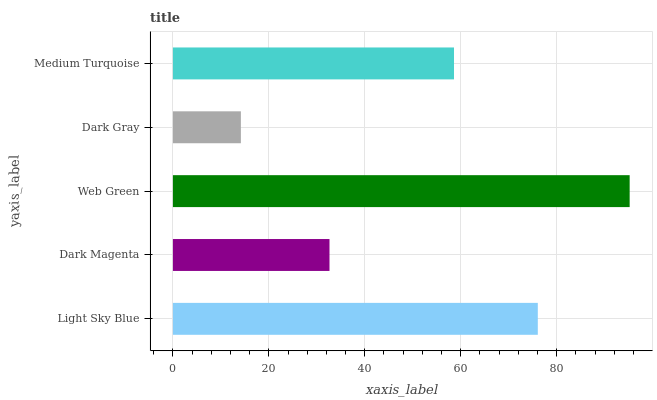Is Dark Gray the minimum?
Answer yes or no. Yes. Is Web Green the maximum?
Answer yes or no. Yes. Is Dark Magenta the minimum?
Answer yes or no. No. Is Dark Magenta the maximum?
Answer yes or no. No. Is Light Sky Blue greater than Dark Magenta?
Answer yes or no. Yes. Is Dark Magenta less than Light Sky Blue?
Answer yes or no. Yes. Is Dark Magenta greater than Light Sky Blue?
Answer yes or no. No. Is Light Sky Blue less than Dark Magenta?
Answer yes or no. No. Is Medium Turquoise the high median?
Answer yes or no. Yes. Is Medium Turquoise the low median?
Answer yes or no. Yes. Is Dark Gray the high median?
Answer yes or no. No. Is Web Green the low median?
Answer yes or no. No. 